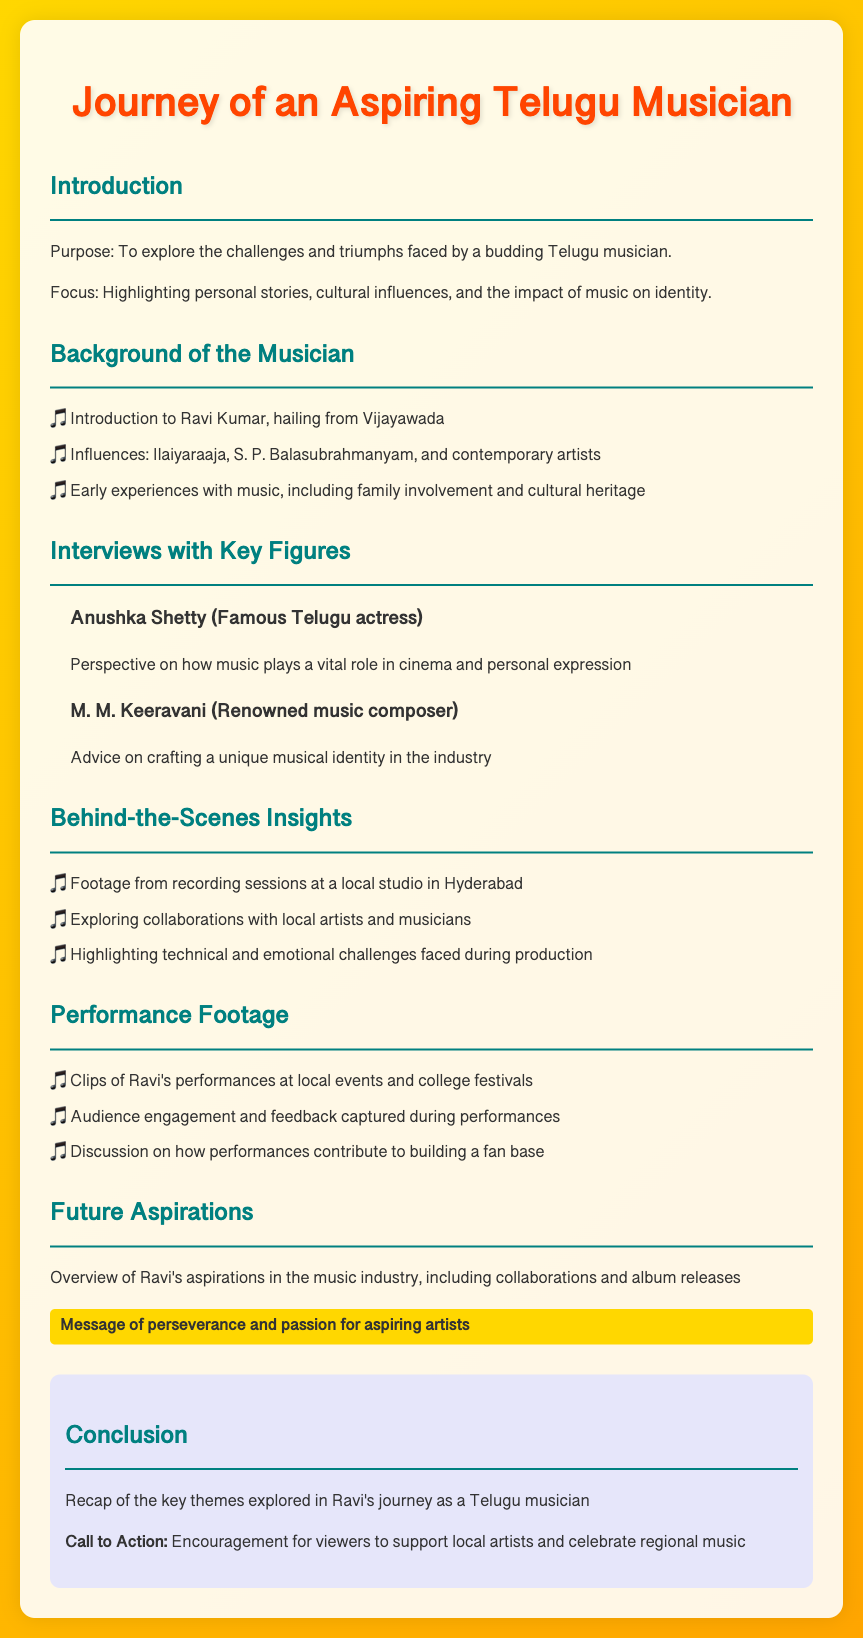What is the purpose of the documentary? The purpose of the documentary is to explore the challenges and triumphs faced by a budding Telugu musician.
Answer: To explore the challenges and triumphs faced by a budding Telugu musician Who is the musician featured in the documentary? The document mentions that the musician featured is Ravi Kumar, who hails from Vijayawada.
Answer: Ravi Kumar Which famous actress is interviewed in the documentary? Anushka Shetty, a famous Telugu actress, is interviewed in the documentary.
Answer: Anushka Shetty What is one of the influences on Ravi Kumar's music? The document lists Ilaiyaraaja as one of Ravi Kumar's musical influences.
Answer: Ilaiyaraaja What message is highlighted in the section about future aspirations? The message emphasized is about perseverance and passion for aspiring artists.
Answer: Perseverance and passion for aspiring artists What type of footage is included in the documentary? The documentary includes performance footage of Ravi's performances at local events and college festivals.
Answer: Performance footage Who gives advice on crafting a unique musical identity? M. M. Keeravani, a renowned music composer, provides advice on this topic.
Answer: M. M. Keeravani What colors are used for the title of the document? The title features the colors #FF4500 for the text.
Answer: #FF4500 